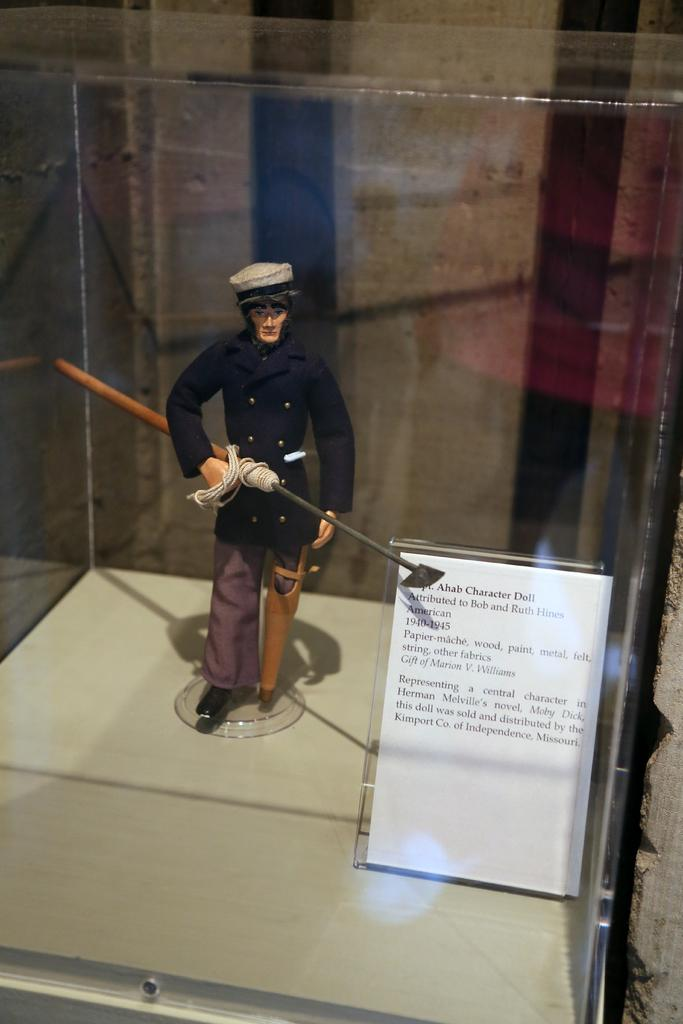What is inside the glass box in the image? There is a toy in a glass box. What is the toy holding in its hands? The toy is holding a weapon. What can be seen beside the glass box? There is a board with text present beside the glass box. What is the toy's reaction to the account of hate in the image? There is no account of hate or any reaction from the toy present in the image. 